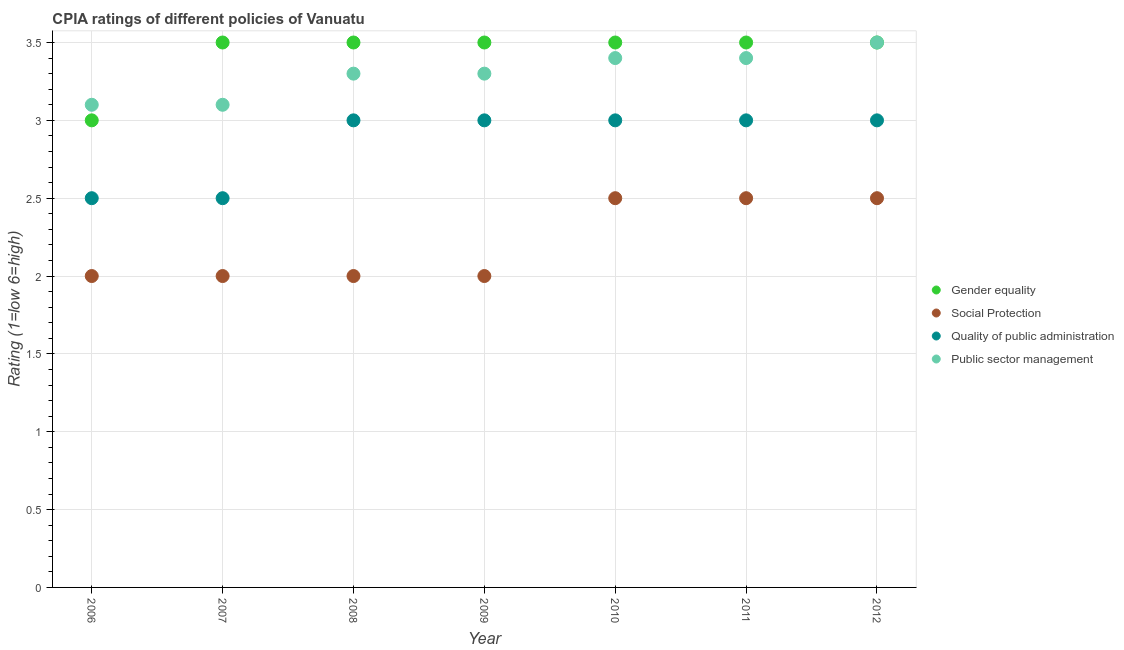How many different coloured dotlines are there?
Your response must be concise. 4. Is the number of dotlines equal to the number of legend labels?
Keep it short and to the point. Yes. What is the cpia rating of gender equality in 2012?
Your answer should be compact. 3.5. Across all years, what is the maximum cpia rating of quality of public administration?
Your answer should be compact. 3. Across all years, what is the minimum cpia rating of quality of public administration?
Ensure brevity in your answer.  2.5. What is the total cpia rating of gender equality in the graph?
Offer a terse response. 24. What is the difference between the cpia rating of public sector management in 2009 and that in 2011?
Your response must be concise. -0.1. What is the difference between the cpia rating of quality of public administration in 2011 and the cpia rating of gender equality in 2007?
Give a very brief answer. -0.5. What is the average cpia rating of social protection per year?
Offer a very short reply. 2.21. In the year 2010, what is the difference between the cpia rating of quality of public administration and cpia rating of public sector management?
Ensure brevity in your answer.  -0.4. What is the ratio of the cpia rating of social protection in 2006 to that in 2012?
Offer a terse response. 0.8. Is the difference between the cpia rating of social protection in 2008 and 2011 greater than the difference between the cpia rating of quality of public administration in 2008 and 2011?
Give a very brief answer. No. What is the difference between the highest and the second highest cpia rating of public sector management?
Provide a short and direct response. 0.1. What is the difference between the highest and the lowest cpia rating of social protection?
Offer a very short reply. 0.5. Is it the case that in every year, the sum of the cpia rating of social protection and cpia rating of gender equality is greater than the sum of cpia rating of public sector management and cpia rating of quality of public administration?
Offer a terse response. No. Is it the case that in every year, the sum of the cpia rating of gender equality and cpia rating of social protection is greater than the cpia rating of quality of public administration?
Keep it short and to the point. Yes. Is the cpia rating of quality of public administration strictly less than the cpia rating of gender equality over the years?
Provide a succinct answer. Yes. How many years are there in the graph?
Keep it short and to the point. 7. What is the title of the graph?
Ensure brevity in your answer.  CPIA ratings of different policies of Vanuatu. What is the label or title of the Y-axis?
Give a very brief answer. Rating (1=low 6=high). What is the Rating (1=low 6=high) in Gender equality in 2006?
Offer a very short reply. 3. What is the Rating (1=low 6=high) of Quality of public administration in 2006?
Ensure brevity in your answer.  2.5. What is the Rating (1=low 6=high) in Gender equality in 2007?
Make the answer very short. 3.5. What is the Rating (1=low 6=high) in Social Protection in 2007?
Your answer should be very brief. 2. What is the Rating (1=low 6=high) of Quality of public administration in 2007?
Your response must be concise. 2.5. What is the Rating (1=low 6=high) in Social Protection in 2008?
Your answer should be very brief. 2. What is the Rating (1=low 6=high) in Quality of public administration in 2008?
Your answer should be very brief. 3. What is the Rating (1=low 6=high) of Public sector management in 2008?
Your response must be concise. 3.3. What is the Rating (1=low 6=high) of Gender equality in 2009?
Your response must be concise. 3.5. What is the Rating (1=low 6=high) of Quality of public administration in 2009?
Provide a succinct answer. 3. What is the Rating (1=low 6=high) in Gender equality in 2010?
Ensure brevity in your answer.  3.5. What is the Rating (1=low 6=high) in Social Protection in 2010?
Your response must be concise. 2.5. What is the Rating (1=low 6=high) of Public sector management in 2010?
Make the answer very short. 3.4. What is the Rating (1=low 6=high) of Gender equality in 2011?
Give a very brief answer. 3.5. What is the Rating (1=low 6=high) of Social Protection in 2011?
Make the answer very short. 2.5. What is the Rating (1=low 6=high) in Public sector management in 2011?
Offer a very short reply. 3.4. What is the Rating (1=low 6=high) of Gender equality in 2012?
Provide a short and direct response. 3.5. What is the Rating (1=low 6=high) of Social Protection in 2012?
Provide a succinct answer. 2.5. Across all years, what is the minimum Rating (1=low 6=high) of Social Protection?
Give a very brief answer. 2. Across all years, what is the minimum Rating (1=low 6=high) of Quality of public administration?
Make the answer very short. 2.5. Across all years, what is the minimum Rating (1=low 6=high) of Public sector management?
Make the answer very short. 3.1. What is the total Rating (1=low 6=high) of Gender equality in the graph?
Ensure brevity in your answer.  24. What is the total Rating (1=low 6=high) in Quality of public administration in the graph?
Offer a very short reply. 20. What is the total Rating (1=low 6=high) of Public sector management in the graph?
Your response must be concise. 23.1. What is the difference between the Rating (1=low 6=high) of Gender equality in 2006 and that in 2007?
Keep it short and to the point. -0.5. What is the difference between the Rating (1=low 6=high) of Quality of public administration in 2006 and that in 2007?
Offer a very short reply. 0. What is the difference between the Rating (1=low 6=high) in Public sector management in 2006 and that in 2007?
Provide a succinct answer. 0. What is the difference between the Rating (1=low 6=high) in Gender equality in 2006 and that in 2008?
Provide a short and direct response. -0.5. What is the difference between the Rating (1=low 6=high) of Public sector management in 2006 and that in 2008?
Keep it short and to the point. -0.2. What is the difference between the Rating (1=low 6=high) of Gender equality in 2006 and that in 2009?
Offer a terse response. -0.5. What is the difference between the Rating (1=low 6=high) in Social Protection in 2006 and that in 2009?
Your answer should be compact. 0. What is the difference between the Rating (1=low 6=high) in Gender equality in 2006 and that in 2010?
Offer a terse response. -0.5. What is the difference between the Rating (1=low 6=high) in Quality of public administration in 2006 and that in 2010?
Ensure brevity in your answer.  -0.5. What is the difference between the Rating (1=low 6=high) in Social Protection in 2006 and that in 2011?
Provide a short and direct response. -0.5. What is the difference between the Rating (1=low 6=high) of Social Protection in 2006 and that in 2012?
Offer a very short reply. -0.5. What is the difference between the Rating (1=low 6=high) of Public sector management in 2006 and that in 2012?
Your answer should be very brief. -0.4. What is the difference between the Rating (1=low 6=high) of Social Protection in 2007 and that in 2008?
Offer a very short reply. 0. What is the difference between the Rating (1=low 6=high) of Quality of public administration in 2007 and that in 2008?
Make the answer very short. -0.5. What is the difference between the Rating (1=low 6=high) of Public sector management in 2007 and that in 2008?
Offer a terse response. -0.2. What is the difference between the Rating (1=low 6=high) of Gender equality in 2007 and that in 2009?
Offer a terse response. 0. What is the difference between the Rating (1=low 6=high) in Quality of public administration in 2007 and that in 2009?
Your response must be concise. -0.5. What is the difference between the Rating (1=low 6=high) in Public sector management in 2007 and that in 2009?
Provide a short and direct response. -0.2. What is the difference between the Rating (1=low 6=high) in Quality of public administration in 2007 and that in 2010?
Make the answer very short. -0.5. What is the difference between the Rating (1=low 6=high) of Gender equality in 2007 and that in 2011?
Your answer should be very brief. 0. What is the difference between the Rating (1=low 6=high) of Quality of public administration in 2007 and that in 2011?
Offer a very short reply. -0.5. What is the difference between the Rating (1=low 6=high) of Social Protection in 2007 and that in 2012?
Your answer should be very brief. -0.5. What is the difference between the Rating (1=low 6=high) in Quality of public administration in 2007 and that in 2012?
Ensure brevity in your answer.  -0.5. What is the difference between the Rating (1=low 6=high) in Public sector management in 2007 and that in 2012?
Offer a very short reply. -0.4. What is the difference between the Rating (1=low 6=high) of Public sector management in 2008 and that in 2009?
Provide a succinct answer. 0. What is the difference between the Rating (1=low 6=high) of Gender equality in 2008 and that in 2010?
Your answer should be compact. 0. What is the difference between the Rating (1=low 6=high) of Social Protection in 2008 and that in 2010?
Give a very brief answer. -0.5. What is the difference between the Rating (1=low 6=high) in Quality of public administration in 2008 and that in 2010?
Provide a succinct answer. 0. What is the difference between the Rating (1=low 6=high) of Quality of public administration in 2008 and that in 2011?
Ensure brevity in your answer.  0. What is the difference between the Rating (1=low 6=high) in Public sector management in 2008 and that in 2011?
Give a very brief answer. -0.1. What is the difference between the Rating (1=low 6=high) of Gender equality in 2008 and that in 2012?
Provide a succinct answer. 0. What is the difference between the Rating (1=low 6=high) of Quality of public administration in 2008 and that in 2012?
Provide a succinct answer. 0. What is the difference between the Rating (1=low 6=high) of Quality of public administration in 2009 and that in 2010?
Provide a succinct answer. 0. What is the difference between the Rating (1=low 6=high) in Public sector management in 2009 and that in 2010?
Offer a very short reply. -0.1. What is the difference between the Rating (1=low 6=high) in Gender equality in 2009 and that in 2011?
Provide a short and direct response. 0. What is the difference between the Rating (1=low 6=high) in Quality of public administration in 2009 and that in 2011?
Make the answer very short. 0. What is the difference between the Rating (1=low 6=high) in Gender equality in 2009 and that in 2012?
Make the answer very short. 0. What is the difference between the Rating (1=low 6=high) of Social Protection in 2009 and that in 2012?
Ensure brevity in your answer.  -0.5. What is the difference between the Rating (1=low 6=high) of Quality of public administration in 2010 and that in 2011?
Provide a short and direct response. 0. What is the difference between the Rating (1=low 6=high) in Public sector management in 2010 and that in 2011?
Give a very brief answer. 0. What is the difference between the Rating (1=low 6=high) of Gender equality in 2010 and that in 2012?
Offer a terse response. 0. What is the difference between the Rating (1=low 6=high) of Gender equality in 2011 and that in 2012?
Offer a terse response. 0. What is the difference between the Rating (1=low 6=high) of Social Protection in 2011 and that in 2012?
Offer a terse response. 0. What is the difference between the Rating (1=low 6=high) of Public sector management in 2011 and that in 2012?
Give a very brief answer. -0.1. What is the difference between the Rating (1=low 6=high) of Social Protection in 2006 and the Rating (1=low 6=high) of Quality of public administration in 2007?
Offer a very short reply. -0.5. What is the difference between the Rating (1=low 6=high) in Social Protection in 2006 and the Rating (1=low 6=high) in Public sector management in 2007?
Make the answer very short. -1.1. What is the difference between the Rating (1=low 6=high) in Gender equality in 2006 and the Rating (1=low 6=high) in Public sector management in 2008?
Give a very brief answer. -0.3. What is the difference between the Rating (1=low 6=high) of Social Protection in 2006 and the Rating (1=low 6=high) of Quality of public administration in 2008?
Offer a very short reply. -1. What is the difference between the Rating (1=low 6=high) in Social Protection in 2006 and the Rating (1=low 6=high) in Public sector management in 2008?
Offer a very short reply. -1.3. What is the difference between the Rating (1=low 6=high) of Quality of public administration in 2006 and the Rating (1=low 6=high) of Public sector management in 2008?
Your response must be concise. -0.8. What is the difference between the Rating (1=low 6=high) of Gender equality in 2006 and the Rating (1=low 6=high) of Social Protection in 2009?
Ensure brevity in your answer.  1. What is the difference between the Rating (1=low 6=high) of Gender equality in 2006 and the Rating (1=low 6=high) of Quality of public administration in 2009?
Provide a succinct answer. 0. What is the difference between the Rating (1=low 6=high) in Gender equality in 2006 and the Rating (1=low 6=high) in Public sector management in 2009?
Give a very brief answer. -0.3. What is the difference between the Rating (1=low 6=high) of Social Protection in 2006 and the Rating (1=low 6=high) of Quality of public administration in 2009?
Your answer should be very brief. -1. What is the difference between the Rating (1=low 6=high) of Quality of public administration in 2006 and the Rating (1=low 6=high) of Public sector management in 2009?
Offer a very short reply. -0.8. What is the difference between the Rating (1=low 6=high) in Gender equality in 2006 and the Rating (1=low 6=high) in Social Protection in 2010?
Your response must be concise. 0.5. What is the difference between the Rating (1=low 6=high) of Gender equality in 2006 and the Rating (1=low 6=high) of Public sector management in 2010?
Ensure brevity in your answer.  -0.4. What is the difference between the Rating (1=low 6=high) in Quality of public administration in 2006 and the Rating (1=low 6=high) in Public sector management in 2010?
Ensure brevity in your answer.  -0.9. What is the difference between the Rating (1=low 6=high) in Gender equality in 2006 and the Rating (1=low 6=high) in Social Protection in 2011?
Offer a very short reply. 0.5. What is the difference between the Rating (1=low 6=high) in Gender equality in 2006 and the Rating (1=low 6=high) in Public sector management in 2011?
Your answer should be very brief. -0.4. What is the difference between the Rating (1=low 6=high) of Gender equality in 2006 and the Rating (1=low 6=high) of Quality of public administration in 2012?
Make the answer very short. 0. What is the difference between the Rating (1=low 6=high) in Gender equality in 2006 and the Rating (1=low 6=high) in Public sector management in 2012?
Offer a very short reply. -0.5. What is the difference between the Rating (1=low 6=high) of Social Protection in 2006 and the Rating (1=low 6=high) of Quality of public administration in 2012?
Offer a very short reply. -1. What is the difference between the Rating (1=low 6=high) of Social Protection in 2006 and the Rating (1=low 6=high) of Public sector management in 2012?
Provide a short and direct response. -1.5. What is the difference between the Rating (1=low 6=high) in Gender equality in 2007 and the Rating (1=low 6=high) in Social Protection in 2008?
Ensure brevity in your answer.  1.5. What is the difference between the Rating (1=low 6=high) in Gender equality in 2007 and the Rating (1=low 6=high) in Quality of public administration in 2008?
Keep it short and to the point. 0.5. What is the difference between the Rating (1=low 6=high) in Gender equality in 2007 and the Rating (1=low 6=high) in Public sector management in 2008?
Ensure brevity in your answer.  0.2. What is the difference between the Rating (1=low 6=high) in Social Protection in 2007 and the Rating (1=low 6=high) in Quality of public administration in 2008?
Make the answer very short. -1. What is the difference between the Rating (1=low 6=high) of Quality of public administration in 2007 and the Rating (1=low 6=high) of Public sector management in 2008?
Offer a terse response. -0.8. What is the difference between the Rating (1=low 6=high) of Gender equality in 2007 and the Rating (1=low 6=high) of Quality of public administration in 2009?
Give a very brief answer. 0.5. What is the difference between the Rating (1=low 6=high) of Quality of public administration in 2007 and the Rating (1=low 6=high) of Public sector management in 2009?
Ensure brevity in your answer.  -0.8. What is the difference between the Rating (1=low 6=high) of Gender equality in 2007 and the Rating (1=low 6=high) of Social Protection in 2010?
Make the answer very short. 1. What is the difference between the Rating (1=low 6=high) in Gender equality in 2007 and the Rating (1=low 6=high) in Quality of public administration in 2010?
Ensure brevity in your answer.  0.5. What is the difference between the Rating (1=low 6=high) of Gender equality in 2007 and the Rating (1=low 6=high) of Public sector management in 2010?
Make the answer very short. 0.1. What is the difference between the Rating (1=low 6=high) of Quality of public administration in 2007 and the Rating (1=low 6=high) of Public sector management in 2010?
Offer a very short reply. -0.9. What is the difference between the Rating (1=low 6=high) of Gender equality in 2007 and the Rating (1=low 6=high) of Quality of public administration in 2011?
Offer a terse response. 0.5. What is the difference between the Rating (1=low 6=high) of Gender equality in 2007 and the Rating (1=low 6=high) of Public sector management in 2011?
Ensure brevity in your answer.  0.1. What is the difference between the Rating (1=low 6=high) in Quality of public administration in 2007 and the Rating (1=low 6=high) in Public sector management in 2011?
Your response must be concise. -0.9. What is the difference between the Rating (1=low 6=high) of Gender equality in 2007 and the Rating (1=low 6=high) of Quality of public administration in 2012?
Keep it short and to the point. 0.5. What is the difference between the Rating (1=low 6=high) of Gender equality in 2007 and the Rating (1=low 6=high) of Public sector management in 2012?
Make the answer very short. 0. What is the difference between the Rating (1=low 6=high) in Social Protection in 2007 and the Rating (1=low 6=high) in Quality of public administration in 2012?
Offer a terse response. -1. What is the difference between the Rating (1=low 6=high) of Social Protection in 2007 and the Rating (1=low 6=high) of Public sector management in 2012?
Provide a succinct answer. -1.5. What is the difference between the Rating (1=low 6=high) of Quality of public administration in 2007 and the Rating (1=low 6=high) of Public sector management in 2012?
Make the answer very short. -1. What is the difference between the Rating (1=low 6=high) in Gender equality in 2008 and the Rating (1=low 6=high) in Quality of public administration in 2009?
Your response must be concise. 0.5. What is the difference between the Rating (1=low 6=high) in Social Protection in 2008 and the Rating (1=low 6=high) in Quality of public administration in 2009?
Your response must be concise. -1. What is the difference between the Rating (1=low 6=high) in Quality of public administration in 2008 and the Rating (1=low 6=high) in Public sector management in 2009?
Your response must be concise. -0.3. What is the difference between the Rating (1=low 6=high) in Gender equality in 2008 and the Rating (1=low 6=high) in Social Protection in 2010?
Provide a short and direct response. 1. What is the difference between the Rating (1=low 6=high) in Gender equality in 2008 and the Rating (1=low 6=high) in Quality of public administration in 2010?
Offer a very short reply. 0.5. What is the difference between the Rating (1=low 6=high) of Social Protection in 2008 and the Rating (1=low 6=high) of Public sector management in 2010?
Provide a succinct answer. -1.4. What is the difference between the Rating (1=low 6=high) of Quality of public administration in 2008 and the Rating (1=low 6=high) of Public sector management in 2010?
Provide a short and direct response. -0.4. What is the difference between the Rating (1=low 6=high) in Gender equality in 2008 and the Rating (1=low 6=high) in Social Protection in 2011?
Provide a short and direct response. 1. What is the difference between the Rating (1=low 6=high) of Social Protection in 2008 and the Rating (1=low 6=high) of Quality of public administration in 2011?
Keep it short and to the point. -1. What is the difference between the Rating (1=low 6=high) of Social Protection in 2008 and the Rating (1=low 6=high) of Public sector management in 2011?
Your answer should be compact. -1.4. What is the difference between the Rating (1=low 6=high) of Quality of public administration in 2008 and the Rating (1=low 6=high) of Public sector management in 2011?
Give a very brief answer. -0.4. What is the difference between the Rating (1=low 6=high) in Gender equality in 2008 and the Rating (1=low 6=high) in Quality of public administration in 2012?
Give a very brief answer. 0.5. What is the difference between the Rating (1=low 6=high) of Gender equality in 2009 and the Rating (1=low 6=high) of Quality of public administration in 2010?
Ensure brevity in your answer.  0.5. What is the difference between the Rating (1=low 6=high) of Social Protection in 2009 and the Rating (1=low 6=high) of Quality of public administration in 2010?
Your answer should be compact. -1. What is the difference between the Rating (1=low 6=high) in Gender equality in 2009 and the Rating (1=low 6=high) in Public sector management in 2011?
Your response must be concise. 0.1. What is the difference between the Rating (1=low 6=high) in Social Protection in 2009 and the Rating (1=low 6=high) in Quality of public administration in 2011?
Your response must be concise. -1. What is the difference between the Rating (1=low 6=high) of Social Protection in 2009 and the Rating (1=low 6=high) of Public sector management in 2011?
Offer a very short reply. -1.4. What is the difference between the Rating (1=low 6=high) of Social Protection in 2009 and the Rating (1=low 6=high) of Public sector management in 2012?
Keep it short and to the point. -1.5. What is the difference between the Rating (1=low 6=high) of Gender equality in 2010 and the Rating (1=low 6=high) of Social Protection in 2011?
Provide a succinct answer. 1. What is the difference between the Rating (1=low 6=high) in Gender equality in 2010 and the Rating (1=low 6=high) in Quality of public administration in 2011?
Your answer should be very brief. 0.5. What is the difference between the Rating (1=low 6=high) of Social Protection in 2010 and the Rating (1=low 6=high) of Quality of public administration in 2011?
Your answer should be very brief. -0.5. What is the difference between the Rating (1=low 6=high) in Quality of public administration in 2010 and the Rating (1=low 6=high) in Public sector management in 2011?
Provide a short and direct response. -0.4. What is the difference between the Rating (1=low 6=high) in Social Protection in 2010 and the Rating (1=low 6=high) in Quality of public administration in 2012?
Provide a short and direct response. -0.5. What is the difference between the Rating (1=low 6=high) in Social Protection in 2010 and the Rating (1=low 6=high) in Public sector management in 2012?
Your answer should be compact. -1. What is the difference between the Rating (1=low 6=high) in Gender equality in 2011 and the Rating (1=low 6=high) in Quality of public administration in 2012?
Offer a terse response. 0.5. What is the difference between the Rating (1=low 6=high) in Social Protection in 2011 and the Rating (1=low 6=high) in Quality of public administration in 2012?
Make the answer very short. -0.5. What is the difference between the Rating (1=low 6=high) of Social Protection in 2011 and the Rating (1=low 6=high) of Public sector management in 2012?
Provide a succinct answer. -1. What is the difference between the Rating (1=low 6=high) in Quality of public administration in 2011 and the Rating (1=low 6=high) in Public sector management in 2012?
Your answer should be very brief. -0.5. What is the average Rating (1=low 6=high) in Gender equality per year?
Your answer should be compact. 3.43. What is the average Rating (1=low 6=high) of Social Protection per year?
Offer a very short reply. 2.21. What is the average Rating (1=low 6=high) of Quality of public administration per year?
Offer a very short reply. 2.86. What is the average Rating (1=low 6=high) of Public sector management per year?
Your answer should be very brief. 3.3. In the year 2006, what is the difference between the Rating (1=low 6=high) of Gender equality and Rating (1=low 6=high) of Quality of public administration?
Your response must be concise. 0.5. In the year 2006, what is the difference between the Rating (1=low 6=high) in Gender equality and Rating (1=low 6=high) in Public sector management?
Give a very brief answer. -0.1. In the year 2006, what is the difference between the Rating (1=low 6=high) in Social Protection and Rating (1=low 6=high) in Quality of public administration?
Offer a very short reply. -0.5. In the year 2006, what is the difference between the Rating (1=low 6=high) in Quality of public administration and Rating (1=low 6=high) in Public sector management?
Offer a terse response. -0.6. In the year 2007, what is the difference between the Rating (1=low 6=high) in Gender equality and Rating (1=low 6=high) in Social Protection?
Keep it short and to the point. 1.5. In the year 2007, what is the difference between the Rating (1=low 6=high) of Gender equality and Rating (1=low 6=high) of Quality of public administration?
Offer a terse response. 1. In the year 2007, what is the difference between the Rating (1=low 6=high) of Gender equality and Rating (1=low 6=high) of Public sector management?
Your answer should be very brief. 0.4. In the year 2007, what is the difference between the Rating (1=low 6=high) of Social Protection and Rating (1=low 6=high) of Quality of public administration?
Keep it short and to the point. -0.5. In the year 2007, what is the difference between the Rating (1=low 6=high) of Quality of public administration and Rating (1=low 6=high) of Public sector management?
Your response must be concise. -0.6. In the year 2008, what is the difference between the Rating (1=low 6=high) of Gender equality and Rating (1=low 6=high) of Social Protection?
Your answer should be compact. 1.5. In the year 2008, what is the difference between the Rating (1=low 6=high) of Social Protection and Rating (1=low 6=high) of Public sector management?
Your answer should be very brief. -1.3. In the year 2008, what is the difference between the Rating (1=low 6=high) of Quality of public administration and Rating (1=low 6=high) of Public sector management?
Provide a short and direct response. -0.3. In the year 2009, what is the difference between the Rating (1=low 6=high) in Gender equality and Rating (1=low 6=high) in Social Protection?
Provide a short and direct response. 1.5. In the year 2009, what is the difference between the Rating (1=low 6=high) in Gender equality and Rating (1=low 6=high) in Public sector management?
Offer a very short reply. 0.2. In the year 2009, what is the difference between the Rating (1=low 6=high) of Social Protection and Rating (1=low 6=high) of Public sector management?
Keep it short and to the point. -1.3. In the year 2010, what is the difference between the Rating (1=low 6=high) of Gender equality and Rating (1=low 6=high) of Social Protection?
Give a very brief answer. 1. In the year 2010, what is the difference between the Rating (1=low 6=high) of Social Protection and Rating (1=low 6=high) of Public sector management?
Your response must be concise. -0.9. In the year 2011, what is the difference between the Rating (1=low 6=high) of Gender equality and Rating (1=low 6=high) of Quality of public administration?
Offer a terse response. 0.5. In the year 2012, what is the difference between the Rating (1=low 6=high) in Gender equality and Rating (1=low 6=high) in Social Protection?
Offer a very short reply. 1. In the year 2012, what is the difference between the Rating (1=low 6=high) of Social Protection and Rating (1=low 6=high) of Quality of public administration?
Your response must be concise. -0.5. In the year 2012, what is the difference between the Rating (1=low 6=high) of Social Protection and Rating (1=low 6=high) of Public sector management?
Give a very brief answer. -1. In the year 2012, what is the difference between the Rating (1=low 6=high) in Quality of public administration and Rating (1=low 6=high) in Public sector management?
Offer a terse response. -0.5. What is the ratio of the Rating (1=low 6=high) of Gender equality in 2006 to that in 2007?
Keep it short and to the point. 0.86. What is the ratio of the Rating (1=low 6=high) of Social Protection in 2006 to that in 2007?
Offer a terse response. 1. What is the ratio of the Rating (1=low 6=high) in Quality of public administration in 2006 to that in 2007?
Provide a succinct answer. 1. What is the ratio of the Rating (1=low 6=high) in Gender equality in 2006 to that in 2008?
Offer a very short reply. 0.86. What is the ratio of the Rating (1=low 6=high) in Social Protection in 2006 to that in 2008?
Your answer should be compact. 1. What is the ratio of the Rating (1=low 6=high) in Quality of public administration in 2006 to that in 2008?
Offer a terse response. 0.83. What is the ratio of the Rating (1=low 6=high) in Public sector management in 2006 to that in 2008?
Offer a very short reply. 0.94. What is the ratio of the Rating (1=low 6=high) in Gender equality in 2006 to that in 2009?
Make the answer very short. 0.86. What is the ratio of the Rating (1=low 6=high) in Social Protection in 2006 to that in 2009?
Provide a succinct answer. 1. What is the ratio of the Rating (1=low 6=high) of Public sector management in 2006 to that in 2009?
Offer a very short reply. 0.94. What is the ratio of the Rating (1=low 6=high) in Public sector management in 2006 to that in 2010?
Your answer should be compact. 0.91. What is the ratio of the Rating (1=low 6=high) of Gender equality in 2006 to that in 2011?
Make the answer very short. 0.86. What is the ratio of the Rating (1=low 6=high) in Social Protection in 2006 to that in 2011?
Your response must be concise. 0.8. What is the ratio of the Rating (1=low 6=high) of Quality of public administration in 2006 to that in 2011?
Provide a succinct answer. 0.83. What is the ratio of the Rating (1=low 6=high) in Public sector management in 2006 to that in 2011?
Keep it short and to the point. 0.91. What is the ratio of the Rating (1=low 6=high) of Gender equality in 2006 to that in 2012?
Give a very brief answer. 0.86. What is the ratio of the Rating (1=low 6=high) in Public sector management in 2006 to that in 2012?
Give a very brief answer. 0.89. What is the ratio of the Rating (1=low 6=high) of Gender equality in 2007 to that in 2008?
Your answer should be very brief. 1. What is the ratio of the Rating (1=low 6=high) of Social Protection in 2007 to that in 2008?
Offer a very short reply. 1. What is the ratio of the Rating (1=low 6=high) of Quality of public administration in 2007 to that in 2008?
Your answer should be compact. 0.83. What is the ratio of the Rating (1=low 6=high) of Public sector management in 2007 to that in 2008?
Offer a very short reply. 0.94. What is the ratio of the Rating (1=low 6=high) of Gender equality in 2007 to that in 2009?
Your answer should be compact. 1. What is the ratio of the Rating (1=low 6=high) in Quality of public administration in 2007 to that in 2009?
Provide a short and direct response. 0.83. What is the ratio of the Rating (1=low 6=high) of Public sector management in 2007 to that in 2009?
Offer a terse response. 0.94. What is the ratio of the Rating (1=low 6=high) of Gender equality in 2007 to that in 2010?
Ensure brevity in your answer.  1. What is the ratio of the Rating (1=low 6=high) in Social Protection in 2007 to that in 2010?
Your answer should be very brief. 0.8. What is the ratio of the Rating (1=low 6=high) in Public sector management in 2007 to that in 2010?
Provide a short and direct response. 0.91. What is the ratio of the Rating (1=low 6=high) of Quality of public administration in 2007 to that in 2011?
Provide a succinct answer. 0.83. What is the ratio of the Rating (1=low 6=high) in Public sector management in 2007 to that in 2011?
Your response must be concise. 0.91. What is the ratio of the Rating (1=low 6=high) in Gender equality in 2007 to that in 2012?
Ensure brevity in your answer.  1. What is the ratio of the Rating (1=low 6=high) in Quality of public administration in 2007 to that in 2012?
Keep it short and to the point. 0.83. What is the ratio of the Rating (1=low 6=high) of Public sector management in 2007 to that in 2012?
Your response must be concise. 0.89. What is the ratio of the Rating (1=low 6=high) in Gender equality in 2008 to that in 2009?
Offer a terse response. 1. What is the ratio of the Rating (1=low 6=high) of Social Protection in 2008 to that in 2009?
Your answer should be compact. 1. What is the ratio of the Rating (1=low 6=high) in Quality of public administration in 2008 to that in 2009?
Your response must be concise. 1. What is the ratio of the Rating (1=low 6=high) in Gender equality in 2008 to that in 2010?
Your response must be concise. 1. What is the ratio of the Rating (1=low 6=high) of Quality of public administration in 2008 to that in 2010?
Give a very brief answer. 1. What is the ratio of the Rating (1=low 6=high) in Public sector management in 2008 to that in 2010?
Your response must be concise. 0.97. What is the ratio of the Rating (1=low 6=high) of Gender equality in 2008 to that in 2011?
Offer a terse response. 1. What is the ratio of the Rating (1=low 6=high) in Public sector management in 2008 to that in 2011?
Ensure brevity in your answer.  0.97. What is the ratio of the Rating (1=low 6=high) of Public sector management in 2008 to that in 2012?
Give a very brief answer. 0.94. What is the ratio of the Rating (1=low 6=high) in Social Protection in 2009 to that in 2010?
Provide a succinct answer. 0.8. What is the ratio of the Rating (1=low 6=high) in Public sector management in 2009 to that in 2010?
Your answer should be compact. 0.97. What is the ratio of the Rating (1=low 6=high) in Gender equality in 2009 to that in 2011?
Your response must be concise. 1. What is the ratio of the Rating (1=low 6=high) of Social Protection in 2009 to that in 2011?
Provide a succinct answer. 0.8. What is the ratio of the Rating (1=low 6=high) in Quality of public administration in 2009 to that in 2011?
Make the answer very short. 1. What is the ratio of the Rating (1=low 6=high) in Public sector management in 2009 to that in 2011?
Provide a short and direct response. 0.97. What is the ratio of the Rating (1=low 6=high) of Social Protection in 2009 to that in 2012?
Provide a succinct answer. 0.8. What is the ratio of the Rating (1=low 6=high) of Quality of public administration in 2009 to that in 2012?
Provide a short and direct response. 1. What is the ratio of the Rating (1=low 6=high) in Public sector management in 2009 to that in 2012?
Make the answer very short. 0.94. What is the ratio of the Rating (1=low 6=high) in Gender equality in 2010 to that in 2011?
Ensure brevity in your answer.  1. What is the ratio of the Rating (1=low 6=high) in Social Protection in 2010 to that in 2011?
Offer a very short reply. 1. What is the ratio of the Rating (1=low 6=high) of Social Protection in 2010 to that in 2012?
Your answer should be very brief. 1. What is the ratio of the Rating (1=low 6=high) in Public sector management in 2010 to that in 2012?
Offer a very short reply. 0.97. What is the ratio of the Rating (1=low 6=high) of Gender equality in 2011 to that in 2012?
Ensure brevity in your answer.  1. What is the ratio of the Rating (1=low 6=high) in Social Protection in 2011 to that in 2012?
Your answer should be very brief. 1. What is the ratio of the Rating (1=low 6=high) of Public sector management in 2011 to that in 2012?
Your answer should be very brief. 0.97. What is the difference between the highest and the second highest Rating (1=low 6=high) of Social Protection?
Offer a very short reply. 0. What is the difference between the highest and the second highest Rating (1=low 6=high) in Quality of public administration?
Your response must be concise. 0. What is the difference between the highest and the lowest Rating (1=low 6=high) in Quality of public administration?
Provide a succinct answer. 0.5. What is the difference between the highest and the lowest Rating (1=low 6=high) of Public sector management?
Offer a very short reply. 0.4. 